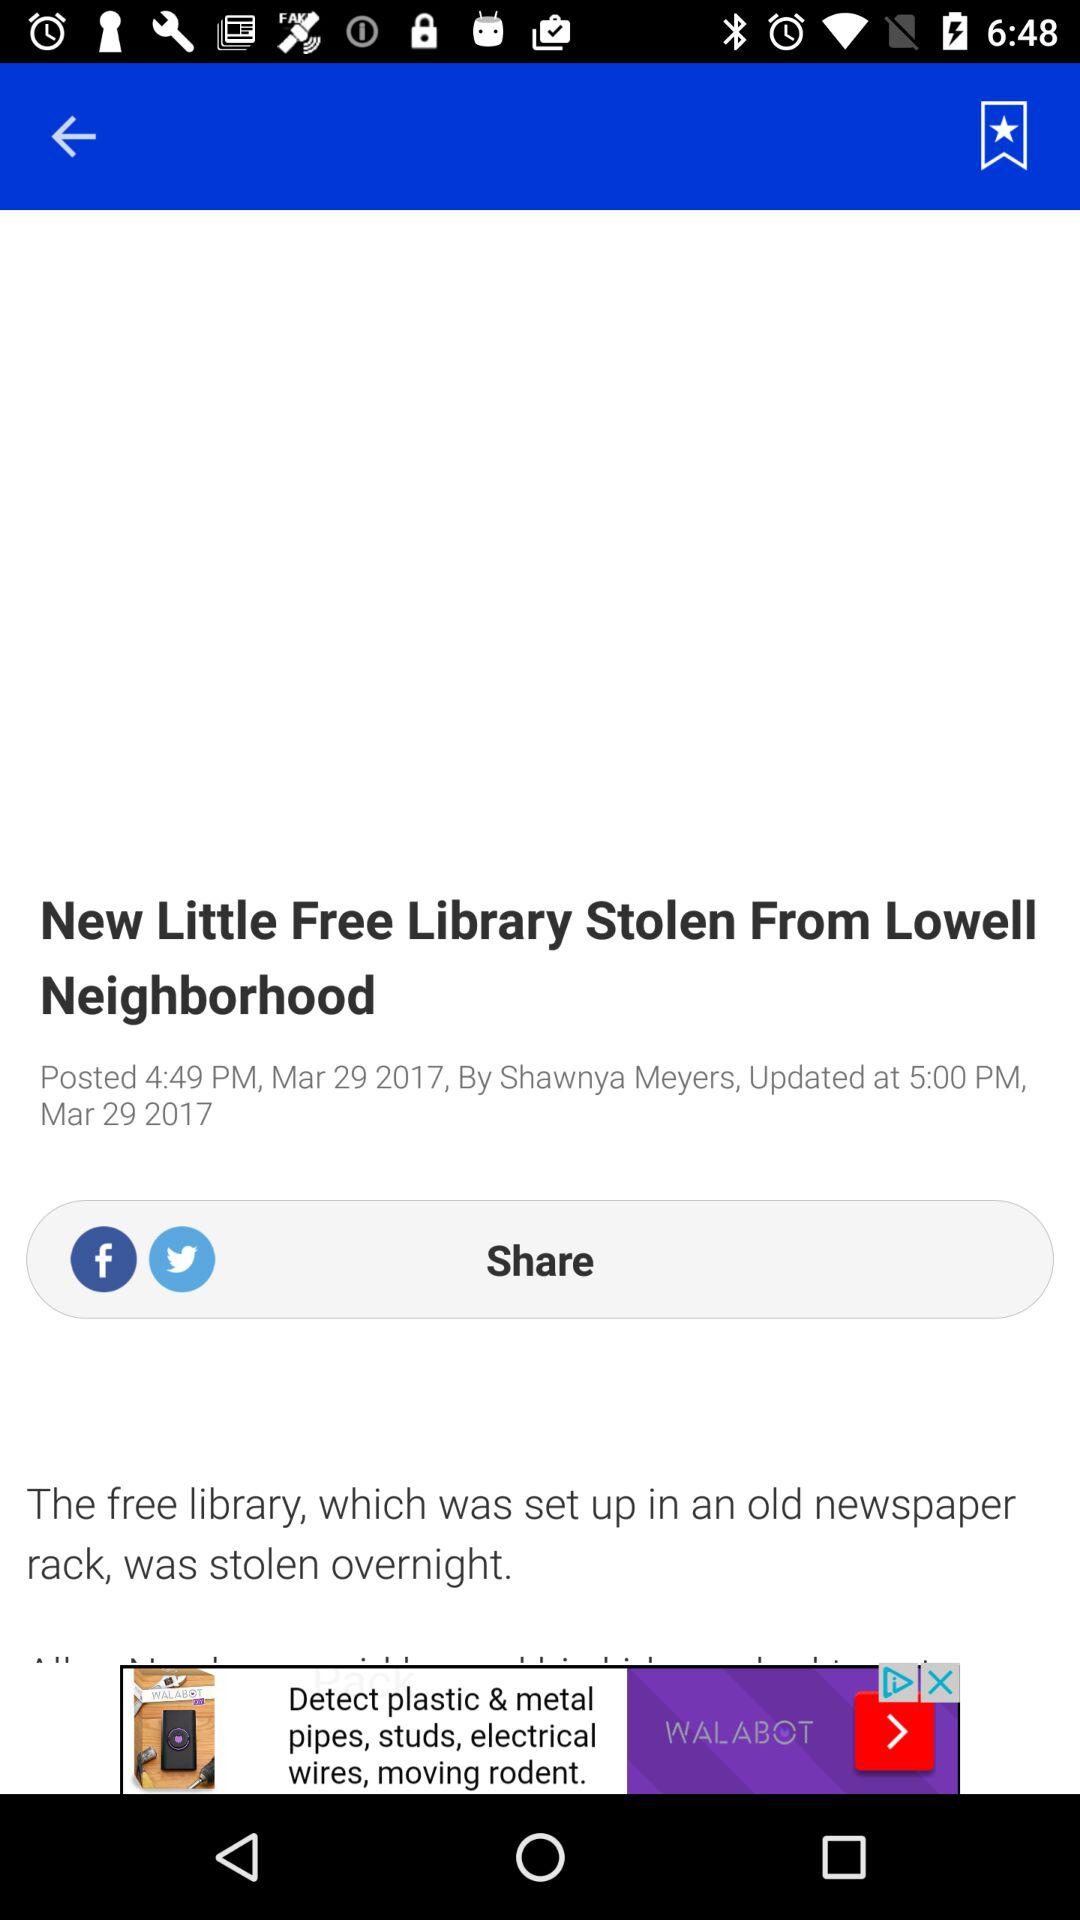What is the updated time of the article? The updated time of the article is 5:00 PM. 